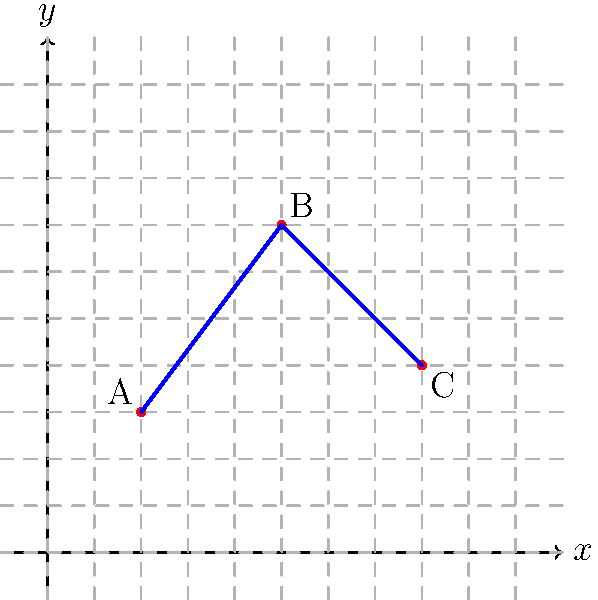During a severe snowstorm, you need to plot a safe driving route on a city map represented by a coordinate system. Three critical locations have been identified: the weather station (A) at (2, 3), an emergency shelter (B) at (5, 7), and a hospital (C) at (8, 4). What is the total distance of the safest route from the weather station to the hospital, passing through the emergency shelter, rounded to the nearest whole number? To find the total distance of the safest route, we need to calculate the distance from A to B and then from B to C using the distance formula, and then add these distances together.

1. Distance formula: $d = \sqrt{(x_2-x_1)^2 + (y_2-y_1)^2}$

2. Distance from A(2, 3) to B(5, 7):
   $d_{AB} = \sqrt{(5-2)^2 + (7-3)^2} = \sqrt{3^2 + 4^2} = \sqrt{9 + 16} = \sqrt{25} = 5$

3. Distance from B(5, 7) to C(8, 4):
   $d_{BC} = \sqrt{(8-5)^2 + (4-7)^2} = \sqrt{3^2 + (-3)^2} = \sqrt{9 + 9} = \sqrt{18} \approx 4.24$

4. Total distance:
   $d_{total} = d_{AB} + d_{BC} = 5 + 4.24 = 9.24$

5. Rounding to the nearest whole number:
   $9.24$ rounds to $9$

Therefore, the total distance of the safest route, rounded to the nearest whole number, is 9 units.
Answer: 9 units 